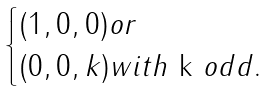Convert formula to latex. <formula><loc_0><loc_0><loc_500><loc_500>\begin{cases} ( 1 , 0 , 0 ) o r \\ ( 0 , 0 , k ) w i t h $ k $ o d d . \end{cases}</formula> 